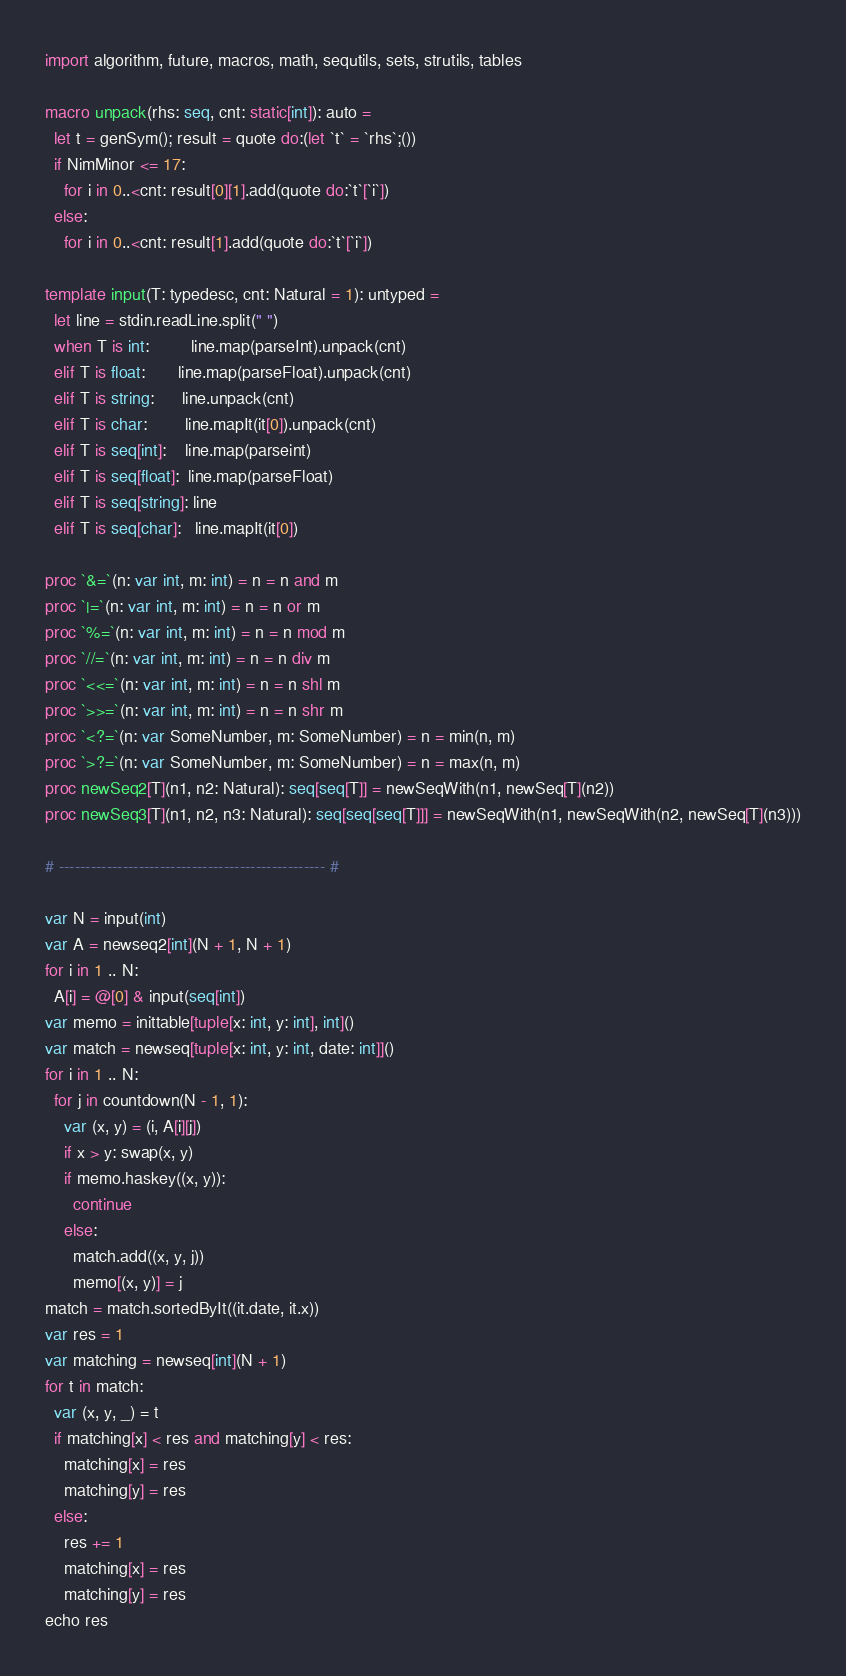<code> <loc_0><loc_0><loc_500><loc_500><_Nim_>import algorithm, future, macros, math, sequtils, sets, strutils, tables

macro unpack(rhs: seq, cnt: static[int]): auto =
  let t = genSym(); result = quote do:(let `t` = `rhs`;())
  if NimMinor <= 17:
    for i in 0..<cnt: result[0][1].add(quote do:`t`[`i`])
  else:
    for i in 0..<cnt: result[1].add(quote do:`t`[`i`])

template input(T: typedesc, cnt: Natural = 1): untyped =
  let line = stdin.readLine.split(" ")
  when T is int:         line.map(parseInt).unpack(cnt)
  elif T is float:       line.map(parseFloat).unpack(cnt)
  elif T is string:      line.unpack(cnt)
  elif T is char:        line.mapIt(it[0]).unpack(cnt)
  elif T is seq[int]:    line.map(parseint)
  elif T is seq[float]:  line.map(parseFloat)
  elif T is seq[string]: line
  elif T is seq[char]:   line.mapIt(it[0])

proc `&=`(n: var int, m: int) = n = n and m
proc `|=`(n: var int, m: int) = n = n or m
proc `%=`(n: var int, m: int) = n = n mod m
proc `//=`(n: var int, m: int) = n = n div m
proc `<<=`(n: var int, m: int) = n = n shl m
proc `>>=`(n: var int, m: int) = n = n shr m
proc `<?=`(n: var SomeNumber, m: SomeNumber) = n = min(n, m)
proc `>?=`(n: var SomeNumber, m: SomeNumber) = n = max(n, m)
proc newSeq2[T](n1, n2: Natural): seq[seq[T]] = newSeqWith(n1, newSeq[T](n2))
proc newSeq3[T](n1, n2, n3: Natural): seq[seq[seq[T]]] = newSeqWith(n1, newSeqWith(n2, newSeq[T](n3)))

# -------------------------------------------------- #

var N = input(int)
var A = newseq2[int](N + 1, N + 1)
for i in 1 .. N:
  A[i] = @[0] & input(seq[int])
var memo = inittable[tuple[x: int, y: int], int]()
var match = newseq[tuple[x: int, y: int, date: int]]()
for i in 1 .. N:
  for j in countdown(N - 1, 1):
    var (x, y) = (i, A[i][j])
    if x > y: swap(x, y)
    if memo.haskey((x, y)):
      continue
    else:
      match.add((x, y, j))
      memo[(x, y)] = j
match = match.sortedByIt((it.date, it.x))
var res = 1
var matching = newseq[int](N + 1)
for t in match:
  var (x, y, _) = t
  if matching[x] < res and matching[y] < res:
    matching[x] = res
    matching[y] = res
  else:
    res += 1
    matching[x] = res
    matching[y] = res
echo res</code> 